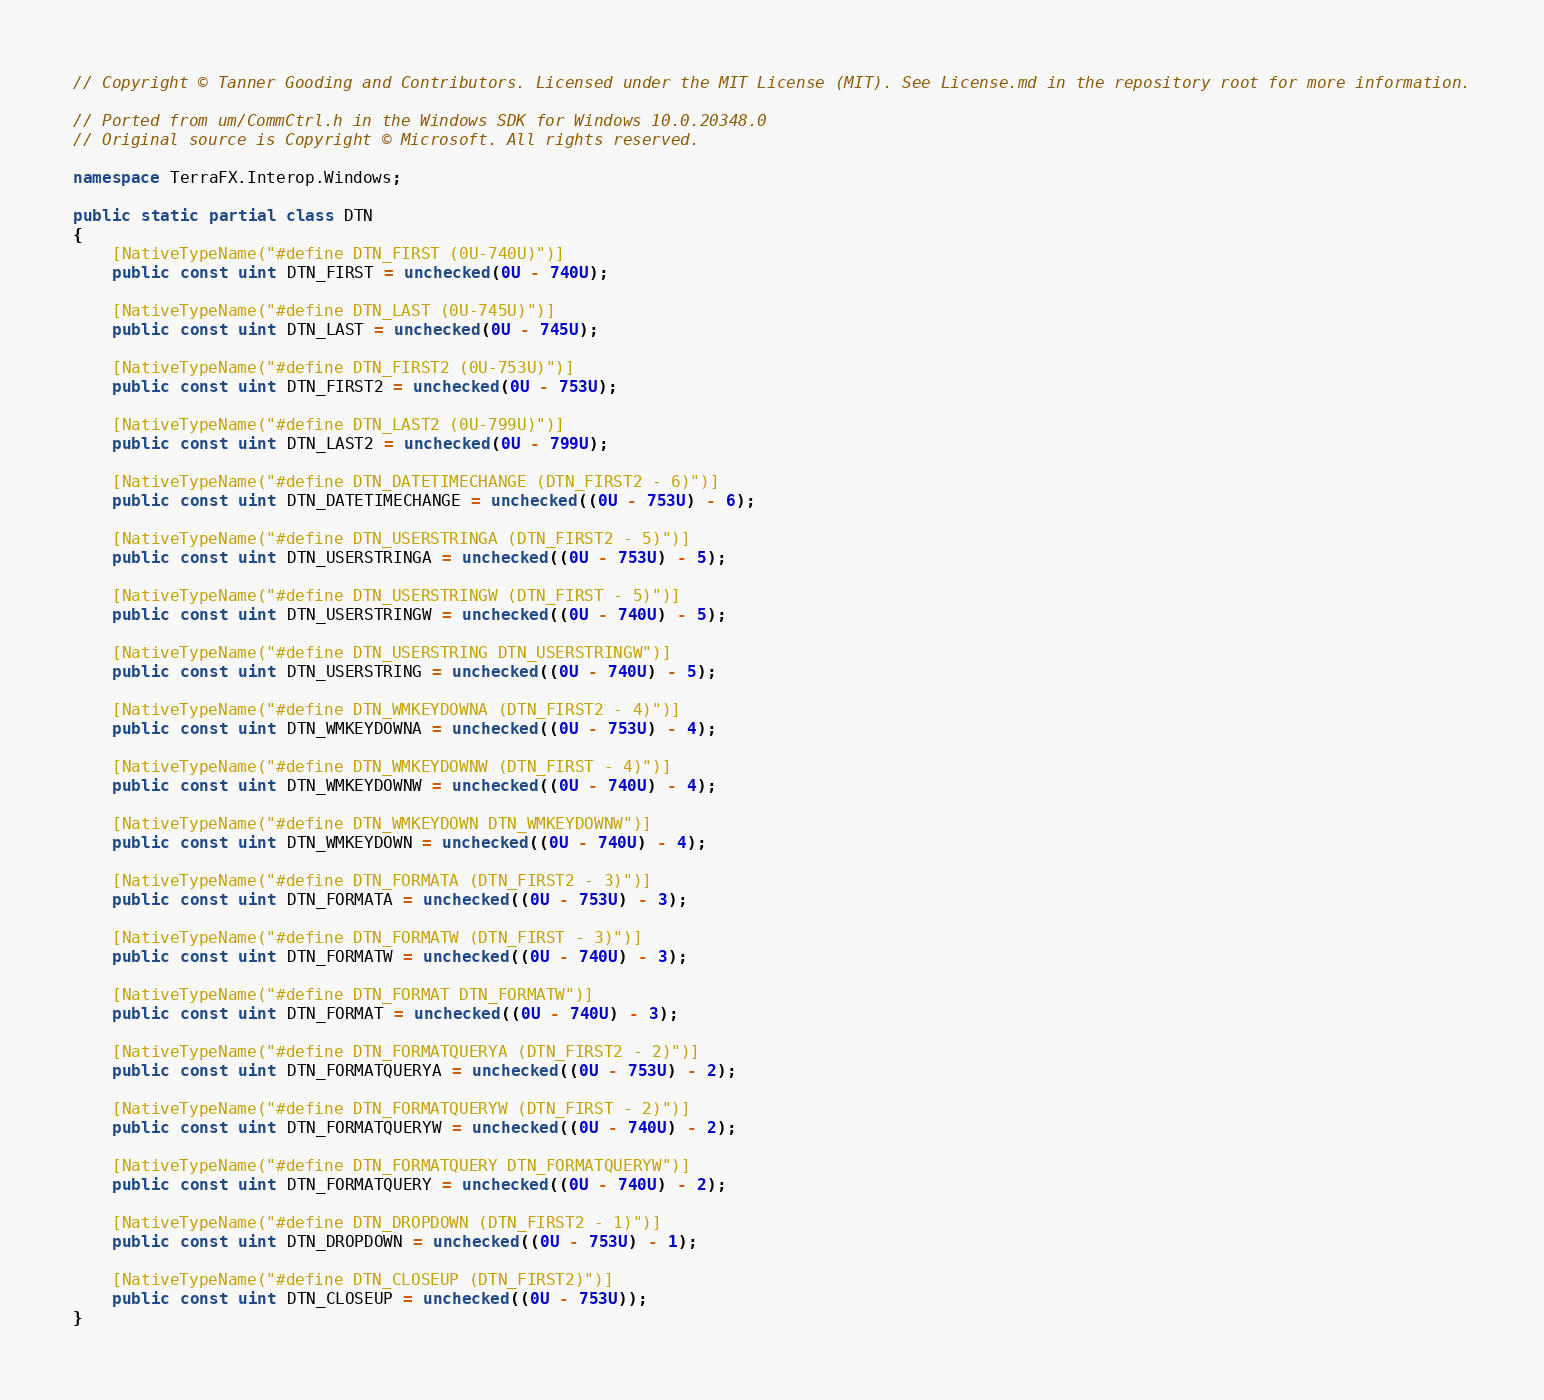<code> <loc_0><loc_0><loc_500><loc_500><_C#_>// Copyright © Tanner Gooding and Contributors. Licensed under the MIT License (MIT). See License.md in the repository root for more information.

// Ported from um/CommCtrl.h in the Windows SDK for Windows 10.0.20348.0
// Original source is Copyright © Microsoft. All rights reserved.

namespace TerraFX.Interop.Windows;

public static partial class DTN
{
    [NativeTypeName("#define DTN_FIRST (0U-740U)")]
    public const uint DTN_FIRST = unchecked(0U - 740U);

    [NativeTypeName("#define DTN_LAST (0U-745U)")]
    public const uint DTN_LAST = unchecked(0U - 745U);

    [NativeTypeName("#define DTN_FIRST2 (0U-753U)")]
    public const uint DTN_FIRST2 = unchecked(0U - 753U);

    [NativeTypeName("#define DTN_LAST2 (0U-799U)")]
    public const uint DTN_LAST2 = unchecked(0U - 799U);

    [NativeTypeName("#define DTN_DATETIMECHANGE (DTN_FIRST2 - 6)")]
    public const uint DTN_DATETIMECHANGE = unchecked((0U - 753U) - 6);

    [NativeTypeName("#define DTN_USERSTRINGA (DTN_FIRST2 - 5)")]
    public const uint DTN_USERSTRINGA = unchecked((0U - 753U) - 5);

    [NativeTypeName("#define DTN_USERSTRINGW (DTN_FIRST - 5)")]
    public const uint DTN_USERSTRINGW = unchecked((0U - 740U) - 5);

    [NativeTypeName("#define DTN_USERSTRING DTN_USERSTRINGW")]
    public const uint DTN_USERSTRING = unchecked((0U - 740U) - 5);

    [NativeTypeName("#define DTN_WMKEYDOWNA (DTN_FIRST2 - 4)")]
    public const uint DTN_WMKEYDOWNA = unchecked((0U - 753U) - 4);

    [NativeTypeName("#define DTN_WMKEYDOWNW (DTN_FIRST - 4)")]
    public const uint DTN_WMKEYDOWNW = unchecked((0U - 740U) - 4);

    [NativeTypeName("#define DTN_WMKEYDOWN DTN_WMKEYDOWNW")]
    public const uint DTN_WMKEYDOWN = unchecked((0U - 740U) - 4);

    [NativeTypeName("#define DTN_FORMATA (DTN_FIRST2 - 3)")]
    public const uint DTN_FORMATA = unchecked((0U - 753U) - 3);

    [NativeTypeName("#define DTN_FORMATW (DTN_FIRST - 3)")]
    public const uint DTN_FORMATW = unchecked((0U - 740U) - 3);

    [NativeTypeName("#define DTN_FORMAT DTN_FORMATW")]
    public const uint DTN_FORMAT = unchecked((0U - 740U) - 3);

    [NativeTypeName("#define DTN_FORMATQUERYA (DTN_FIRST2 - 2)")]
    public const uint DTN_FORMATQUERYA = unchecked((0U - 753U) - 2);

    [NativeTypeName("#define DTN_FORMATQUERYW (DTN_FIRST - 2)")]
    public const uint DTN_FORMATQUERYW = unchecked((0U - 740U) - 2);

    [NativeTypeName("#define DTN_FORMATQUERY DTN_FORMATQUERYW")]
    public const uint DTN_FORMATQUERY = unchecked((0U - 740U) - 2);

    [NativeTypeName("#define DTN_DROPDOWN (DTN_FIRST2 - 1)")]
    public const uint DTN_DROPDOWN = unchecked((0U - 753U) - 1);

    [NativeTypeName("#define DTN_CLOSEUP (DTN_FIRST2)")]
    public const uint DTN_CLOSEUP = unchecked((0U - 753U));
}
</code> 